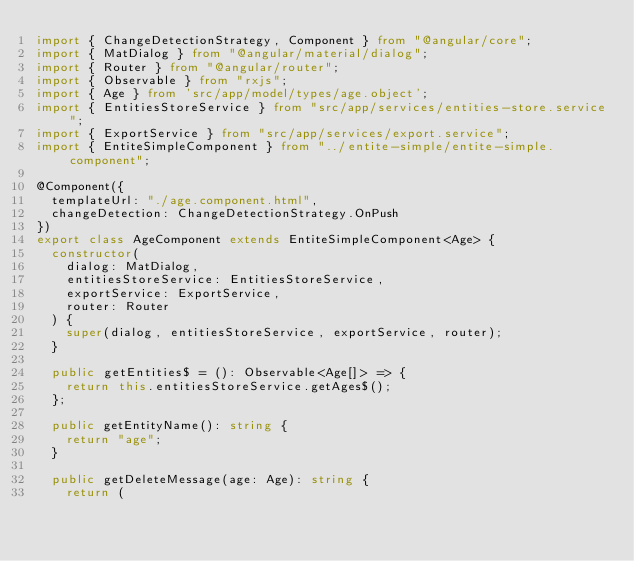Convert code to text. <code><loc_0><loc_0><loc_500><loc_500><_TypeScript_>import { ChangeDetectionStrategy, Component } from "@angular/core";
import { MatDialog } from "@angular/material/dialog";
import { Router } from "@angular/router";
import { Observable } from "rxjs";
import { Age } from 'src/app/model/types/age.object';
import { EntitiesStoreService } from "src/app/services/entities-store.service";
import { ExportService } from "src/app/services/export.service";
import { EntiteSimpleComponent } from "../entite-simple/entite-simple.component";

@Component({
  templateUrl: "./age.component.html",
  changeDetection: ChangeDetectionStrategy.OnPush
})
export class AgeComponent extends EntiteSimpleComponent<Age> {
  constructor(
    dialog: MatDialog,
    entitiesStoreService: EntitiesStoreService,
    exportService: ExportService,
    router: Router
  ) {
    super(dialog, entitiesStoreService, exportService, router);
  }

  public getEntities$ = (): Observable<Age[]> => {
    return this.entitiesStoreService.getAges$();
  };

  public getEntityName(): string {
    return "age";
  }

  public getDeleteMessage(age: Age): string {
    return (</code> 